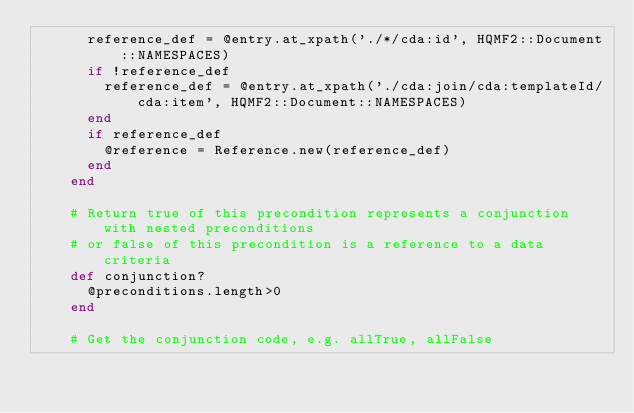Convert code to text. <code><loc_0><loc_0><loc_500><loc_500><_Ruby_>      reference_def = @entry.at_xpath('./*/cda:id', HQMF2::Document::NAMESPACES)
      if !reference_def
        reference_def = @entry.at_xpath('./cda:join/cda:templateId/cda:item', HQMF2::Document::NAMESPACES)
      end
      if reference_def
        @reference = Reference.new(reference_def)
      end
    end
    
    # Return true of this precondition represents a conjunction with nested preconditions
    # or false of this precondition is a reference to a data criteria
    def conjunction?
      @preconditions.length>0
    end
    
    # Get the conjunction code, e.g. allTrue, allFalse</code> 